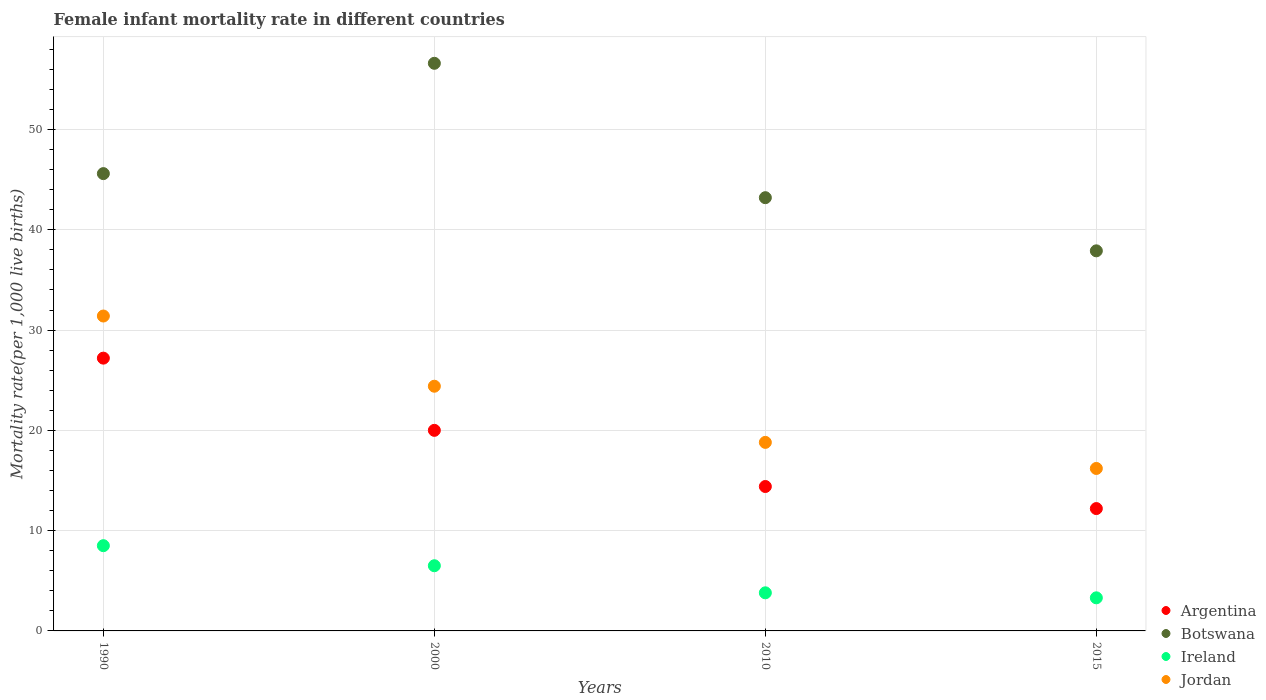What is the female infant mortality rate in Argentina in 2015?
Your answer should be compact. 12.2. Across all years, what is the maximum female infant mortality rate in Jordan?
Keep it short and to the point. 31.4. Across all years, what is the minimum female infant mortality rate in Botswana?
Your response must be concise. 37.9. In which year was the female infant mortality rate in Jordan maximum?
Your answer should be very brief. 1990. In which year was the female infant mortality rate in Botswana minimum?
Offer a very short reply. 2015. What is the total female infant mortality rate in Ireland in the graph?
Offer a very short reply. 22.1. What is the difference between the female infant mortality rate in Argentina in 1990 and that in 2000?
Provide a short and direct response. 7.2. What is the average female infant mortality rate in Botswana per year?
Offer a terse response. 45.83. In the year 1990, what is the difference between the female infant mortality rate in Ireland and female infant mortality rate in Botswana?
Give a very brief answer. -37.1. In how many years, is the female infant mortality rate in Ireland greater than 16?
Keep it short and to the point. 0. What is the ratio of the female infant mortality rate in Argentina in 2010 to that in 2015?
Ensure brevity in your answer.  1.18. Is the female infant mortality rate in Ireland in 1990 less than that in 2000?
Provide a short and direct response. No. What is the difference between the highest and the lowest female infant mortality rate in Botswana?
Your answer should be very brief. 18.7. In how many years, is the female infant mortality rate in Jordan greater than the average female infant mortality rate in Jordan taken over all years?
Provide a short and direct response. 2. Is the sum of the female infant mortality rate in Ireland in 2000 and 2015 greater than the maximum female infant mortality rate in Botswana across all years?
Provide a succinct answer. No. Is it the case that in every year, the sum of the female infant mortality rate in Argentina and female infant mortality rate in Botswana  is greater than the female infant mortality rate in Ireland?
Make the answer very short. Yes. Does the female infant mortality rate in Jordan monotonically increase over the years?
Give a very brief answer. No. Are the values on the major ticks of Y-axis written in scientific E-notation?
Your answer should be very brief. No. Does the graph contain any zero values?
Provide a succinct answer. No. Does the graph contain grids?
Offer a very short reply. Yes. How many legend labels are there?
Offer a terse response. 4. What is the title of the graph?
Keep it short and to the point. Female infant mortality rate in different countries. What is the label or title of the X-axis?
Offer a terse response. Years. What is the label or title of the Y-axis?
Your answer should be very brief. Mortality rate(per 1,0 live births). What is the Mortality rate(per 1,000 live births) in Argentina in 1990?
Provide a succinct answer. 27.2. What is the Mortality rate(per 1,000 live births) in Botswana in 1990?
Offer a very short reply. 45.6. What is the Mortality rate(per 1,000 live births) in Ireland in 1990?
Provide a succinct answer. 8.5. What is the Mortality rate(per 1,000 live births) of Jordan in 1990?
Provide a succinct answer. 31.4. What is the Mortality rate(per 1,000 live births) in Botswana in 2000?
Provide a short and direct response. 56.6. What is the Mortality rate(per 1,000 live births) of Jordan in 2000?
Give a very brief answer. 24.4. What is the Mortality rate(per 1,000 live births) of Botswana in 2010?
Your answer should be compact. 43.2. What is the Mortality rate(per 1,000 live births) in Botswana in 2015?
Your response must be concise. 37.9. Across all years, what is the maximum Mortality rate(per 1,000 live births) of Argentina?
Make the answer very short. 27.2. Across all years, what is the maximum Mortality rate(per 1,000 live births) in Botswana?
Your answer should be compact. 56.6. Across all years, what is the maximum Mortality rate(per 1,000 live births) in Jordan?
Your response must be concise. 31.4. Across all years, what is the minimum Mortality rate(per 1,000 live births) in Botswana?
Your response must be concise. 37.9. Across all years, what is the minimum Mortality rate(per 1,000 live births) of Ireland?
Give a very brief answer. 3.3. What is the total Mortality rate(per 1,000 live births) in Argentina in the graph?
Make the answer very short. 73.8. What is the total Mortality rate(per 1,000 live births) in Botswana in the graph?
Offer a terse response. 183.3. What is the total Mortality rate(per 1,000 live births) of Ireland in the graph?
Give a very brief answer. 22.1. What is the total Mortality rate(per 1,000 live births) of Jordan in the graph?
Offer a very short reply. 90.8. What is the difference between the Mortality rate(per 1,000 live births) of Argentina in 1990 and that in 2000?
Give a very brief answer. 7.2. What is the difference between the Mortality rate(per 1,000 live births) of Ireland in 1990 and that in 2000?
Provide a short and direct response. 2. What is the difference between the Mortality rate(per 1,000 live births) of Argentina in 1990 and that in 2010?
Offer a terse response. 12.8. What is the difference between the Mortality rate(per 1,000 live births) in Botswana in 1990 and that in 2010?
Keep it short and to the point. 2.4. What is the difference between the Mortality rate(per 1,000 live births) in Jordan in 1990 and that in 2015?
Offer a very short reply. 15.2. What is the difference between the Mortality rate(per 1,000 live births) of Botswana in 2000 and that in 2010?
Your answer should be very brief. 13.4. What is the difference between the Mortality rate(per 1,000 live births) in Argentina in 2000 and that in 2015?
Provide a succinct answer. 7.8. What is the difference between the Mortality rate(per 1,000 live births) in Botswana in 2000 and that in 2015?
Your answer should be very brief. 18.7. What is the difference between the Mortality rate(per 1,000 live births) in Ireland in 2000 and that in 2015?
Give a very brief answer. 3.2. What is the difference between the Mortality rate(per 1,000 live births) of Argentina in 2010 and that in 2015?
Your answer should be compact. 2.2. What is the difference between the Mortality rate(per 1,000 live births) in Jordan in 2010 and that in 2015?
Your answer should be very brief. 2.6. What is the difference between the Mortality rate(per 1,000 live births) of Argentina in 1990 and the Mortality rate(per 1,000 live births) of Botswana in 2000?
Provide a succinct answer. -29.4. What is the difference between the Mortality rate(per 1,000 live births) in Argentina in 1990 and the Mortality rate(per 1,000 live births) in Ireland in 2000?
Keep it short and to the point. 20.7. What is the difference between the Mortality rate(per 1,000 live births) in Argentina in 1990 and the Mortality rate(per 1,000 live births) in Jordan in 2000?
Offer a terse response. 2.8. What is the difference between the Mortality rate(per 1,000 live births) in Botswana in 1990 and the Mortality rate(per 1,000 live births) in Ireland in 2000?
Give a very brief answer. 39.1. What is the difference between the Mortality rate(per 1,000 live births) of Botswana in 1990 and the Mortality rate(per 1,000 live births) of Jordan in 2000?
Your answer should be very brief. 21.2. What is the difference between the Mortality rate(per 1,000 live births) of Ireland in 1990 and the Mortality rate(per 1,000 live births) of Jordan in 2000?
Your response must be concise. -15.9. What is the difference between the Mortality rate(per 1,000 live births) of Argentina in 1990 and the Mortality rate(per 1,000 live births) of Botswana in 2010?
Provide a short and direct response. -16. What is the difference between the Mortality rate(per 1,000 live births) in Argentina in 1990 and the Mortality rate(per 1,000 live births) in Ireland in 2010?
Provide a succinct answer. 23.4. What is the difference between the Mortality rate(per 1,000 live births) in Argentina in 1990 and the Mortality rate(per 1,000 live births) in Jordan in 2010?
Ensure brevity in your answer.  8.4. What is the difference between the Mortality rate(per 1,000 live births) of Botswana in 1990 and the Mortality rate(per 1,000 live births) of Ireland in 2010?
Provide a short and direct response. 41.8. What is the difference between the Mortality rate(per 1,000 live births) in Botswana in 1990 and the Mortality rate(per 1,000 live births) in Jordan in 2010?
Offer a very short reply. 26.8. What is the difference between the Mortality rate(per 1,000 live births) in Argentina in 1990 and the Mortality rate(per 1,000 live births) in Ireland in 2015?
Your answer should be compact. 23.9. What is the difference between the Mortality rate(per 1,000 live births) of Argentina in 1990 and the Mortality rate(per 1,000 live births) of Jordan in 2015?
Offer a very short reply. 11. What is the difference between the Mortality rate(per 1,000 live births) of Botswana in 1990 and the Mortality rate(per 1,000 live births) of Ireland in 2015?
Keep it short and to the point. 42.3. What is the difference between the Mortality rate(per 1,000 live births) of Botswana in 1990 and the Mortality rate(per 1,000 live births) of Jordan in 2015?
Give a very brief answer. 29.4. What is the difference between the Mortality rate(per 1,000 live births) in Argentina in 2000 and the Mortality rate(per 1,000 live births) in Botswana in 2010?
Your answer should be very brief. -23.2. What is the difference between the Mortality rate(per 1,000 live births) of Argentina in 2000 and the Mortality rate(per 1,000 live births) of Ireland in 2010?
Your answer should be compact. 16.2. What is the difference between the Mortality rate(per 1,000 live births) in Botswana in 2000 and the Mortality rate(per 1,000 live births) in Ireland in 2010?
Give a very brief answer. 52.8. What is the difference between the Mortality rate(per 1,000 live births) of Botswana in 2000 and the Mortality rate(per 1,000 live births) of Jordan in 2010?
Your answer should be very brief. 37.8. What is the difference between the Mortality rate(per 1,000 live births) of Ireland in 2000 and the Mortality rate(per 1,000 live births) of Jordan in 2010?
Offer a very short reply. -12.3. What is the difference between the Mortality rate(per 1,000 live births) of Argentina in 2000 and the Mortality rate(per 1,000 live births) of Botswana in 2015?
Offer a very short reply. -17.9. What is the difference between the Mortality rate(per 1,000 live births) in Argentina in 2000 and the Mortality rate(per 1,000 live births) in Jordan in 2015?
Offer a terse response. 3.8. What is the difference between the Mortality rate(per 1,000 live births) in Botswana in 2000 and the Mortality rate(per 1,000 live births) in Ireland in 2015?
Give a very brief answer. 53.3. What is the difference between the Mortality rate(per 1,000 live births) of Botswana in 2000 and the Mortality rate(per 1,000 live births) of Jordan in 2015?
Your response must be concise. 40.4. What is the difference between the Mortality rate(per 1,000 live births) in Ireland in 2000 and the Mortality rate(per 1,000 live births) in Jordan in 2015?
Ensure brevity in your answer.  -9.7. What is the difference between the Mortality rate(per 1,000 live births) in Argentina in 2010 and the Mortality rate(per 1,000 live births) in Botswana in 2015?
Provide a succinct answer. -23.5. What is the difference between the Mortality rate(per 1,000 live births) of Argentina in 2010 and the Mortality rate(per 1,000 live births) of Ireland in 2015?
Make the answer very short. 11.1. What is the difference between the Mortality rate(per 1,000 live births) of Argentina in 2010 and the Mortality rate(per 1,000 live births) of Jordan in 2015?
Provide a short and direct response. -1.8. What is the difference between the Mortality rate(per 1,000 live births) in Botswana in 2010 and the Mortality rate(per 1,000 live births) in Ireland in 2015?
Give a very brief answer. 39.9. What is the average Mortality rate(per 1,000 live births) in Argentina per year?
Offer a very short reply. 18.45. What is the average Mortality rate(per 1,000 live births) in Botswana per year?
Give a very brief answer. 45.83. What is the average Mortality rate(per 1,000 live births) in Ireland per year?
Give a very brief answer. 5.53. What is the average Mortality rate(per 1,000 live births) of Jordan per year?
Keep it short and to the point. 22.7. In the year 1990, what is the difference between the Mortality rate(per 1,000 live births) in Argentina and Mortality rate(per 1,000 live births) in Botswana?
Make the answer very short. -18.4. In the year 1990, what is the difference between the Mortality rate(per 1,000 live births) in Argentina and Mortality rate(per 1,000 live births) in Jordan?
Give a very brief answer. -4.2. In the year 1990, what is the difference between the Mortality rate(per 1,000 live births) in Botswana and Mortality rate(per 1,000 live births) in Ireland?
Make the answer very short. 37.1. In the year 1990, what is the difference between the Mortality rate(per 1,000 live births) of Botswana and Mortality rate(per 1,000 live births) of Jordan?
Give a very brief answer. 14.2. In the year 1990, what is the difference between the Mortality rate(per 1,000 live births) in Ireland and Mortality rate(per 1,000 live births) in Jordan?
Your response must be concise. -22.9. In the year 2000, what is the difference between the Mortality rate(per 1,000 live births) of Argentina and Mortality rate(per 1,000 live births) of Botswana?
Your answer should be compact. -36.6. In the year 2000, what is the difference between the Mortality rate(per 1,000 live births) in Argentina and Mortality rate(per 1,000 live births) in Ireland?
Ensure brevity in your answer.  13.5. In the year 2000, what is the difference between the Mortality rate(per 1,000 live births) of Botswana and Mortality rate(per 1,000 live births) of Ireland?
Provide a succinct answer. 50.1. In the year 2000, what is the difference between the Mortality rate(per 1,000 live births) in Botswana and Mortality rate(per 1,000 live births) in Jordan?
Your answer should be compact. 32.2. In the year 2000, what is the difference between the Mortality rate(per 1,000 live births) of Ireland and Mortality rate(per 1,000 live births) of Jordan?
Your answer should be very brief. -17.9. In the year 2010, what is the difference between the Mortality rate(per 1,000 live births) in Argentina and Mortality rate(per 1,000 live births) in Botswana?
Provide a short and direct response. -28.8. In the year 2010, what is the difference between the Mortality rate(per 1,000 live births) of Argentina and Mortality rate(per 1,000 live births) of Ireland?
Give a very brief answer. 10.6. In the year 2010, what is the difference between the Mortality rate(per 1,000 live births) of Argentina and Mortality rate(per 1,000 live births) of Jordan?
Offer a very short reply. -4.4. In the year 2010, what is the difference between the Mortality rate(per 1,000 live births) in Botswana and Mortality rate(per 1,000 live births) in Ireland?
Your answer should be compact. 39.4. In the year 2010, what is the difference between the Mortality rate(per 1,000 live births) of Botswana and Mortality rate(per 1,000 live births) of Jordan?
Make the answer very short. 24.4. In the year 2015, what is the difference between the Mortality rate(per 1,000 live births) of Argentina and Mortality rate(per 1,000 live births) of Botswana?
Keep it short and to the point. -25.7. In the year 2015, what is the difference between the Mortality rate(per 1,000 live births) of Argentina and Mortality rate(per 1,000 live births) of Ireland?
Make the answer very short. 8.9. In the year 2015, what is the difference between the Mortality rate(per 1,000 live births) in Argentina and Mortality rate(per 1,000 live births) in Jordan?
Your answer should be compact. -4. In the year 2015, what is the difference between the Mortality rate(per 1,000 live births) of Botswana and Mortality rate(per 1,000 live births) of Ireland?
Your response must be concise. 34.6. In the year 2015, what is the difference between the Mortality rate(per 1,000 live births) of Botswana and Mortality rate(per 1,000 live births) of Jordan?
Your answer should be very brief. 21.7. What is the ratio of the Mortality rate(per 1,000 live births) of Argentina in 1990 to that in 2000?
Ensure brevity in your answer.  1.36. What is the ratio of the Mortality rate(per 1,000 live births) of Botswana in 1990 to that in 2000?
Your response must be concise. 0.81. What is the ratio of the Mortality rate(per 1,000 live births) in Ireland in 1990 to that in 2000?
Offer a terse response. 1.31. What is the ratio of the Mortality rate(per 1,000 live births) of Jordan in 1990 to that in 2000?
Make the answer very short. 1.29. What is the ratio of the Mortality rate(per 1,000 live births) in Argentina in 1990 to that in 2010?
Your answer should be compact. 1.89. What is the ratio of the Mortality rate(per 1,000 live births) of Botswana in 1990 to that in 2010?
Offer a very short reply. 1.06. What is the ratio of the Mortality rate(per 1,000 live births) of Ireland in 1990 to that in 2010?
Keep it short and to the point. 2.24. What is the ratio of the Mortality rate(per 1,000 live births) in Jordan in 1990 to that in 2010?
Ensure brevity in your answer.  1.67. What is the ratio of the Mortality rate(per 1,000 live births) of Argentina in 1990 to that in 2015?
Your response must be concise. 2.23. What is the ratio of the Mortality rate(per 1,000 live births) of Botswana in 1990 to that in 2015?
Your answer should be very brief. 1.2. What is the ratio of the Mortality rate(per 1,000 live births) of Ireland in 1990 to that in 2015?
Give a very brief answer. 2.58. What is the ratio of the Mortality rate(per 1,000 live births) in Jordan in 1990 to that in 2015?
Ensure brevity in your answer.  1.94. What is the ratio of the Mortality rate(per 1,000 live births) of Argentina in 2000 to that in 2010?
Your response must be concise. 1.39. What is the ratio of the Mortality rate(per 1,000 live births) of Botswana in 2000 to that in 2010?
Your answer should be compact. 1.31. What is the ratio of the Mortality rate(per 1,000 live births) in Ireland in 2000 to that in 2010?
Ensure brevity in your answer.  1.71. What is the ratio of the Mortality rate(per 1,000 live births) in Jordan in 2000 to that in 2010?
Your response must be concise. 1.3. What is the ratio of the Mortality rate(per 1,000 live births) of Argentina in 2000 to that in 2015?
Your answer should be very brief. 1.64. What is the ratio of the Mortality rate(per 1,000 live births) in Botswana in 2000 to that in 2015?
Provide a short and direct response. 1.49. What is the ratio of the Mortality rate(per 1,000 live births) of Ireland in 2000 to that in 2015?
Your answer should be very brief. 1.97. What is the ratio of the Mortality rate(per 1,000 live births) of Jordan in 2000 to that in 2015?
Ensure brevity in your answer.  1.51. What is the ratio of the Mortality rate(per 1,000 live births) of Argentina in 2010 to that in 2015?
Provide a short and direct response. 1.18. What is the ratio of the Mortality rate(per 1,000 live births) in Botswana in 2010 to that in 2015?
Your answer should be very brief. 1.14. What is the ratio of the Mortality rate(per 1,000 live births) of Ireland in 2010 to that in 2015?
Offer a terse response. 1.15. What is the ratio of the Mortality rate(per 1,000 live births) in Jordan in 2010 to that in 2015?
Provide a succinct answer. 1.16. What is the difference between the highest and the second highest Mortality rate(per 1,000 live births) of Ireland?
Your answer should be very brief. 2. What is the difference between the highest and the lowest Mortality rate(per 1,000 live births) of Jordan?
Ensure brevity in your answer.  15.2. 